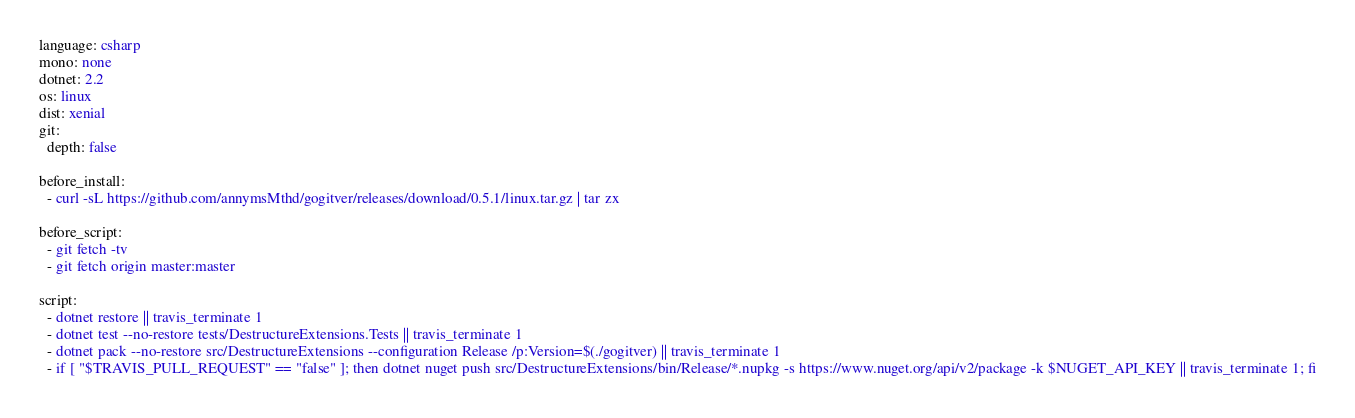<code> <loc_0><loc_0><loc_500><loc_500><_YAML_>language: csharp
mono: none
dotnet: 2.2
os: linux
dist: xenial
git:
  depth: false

before_install:
  - curl -sL https://github.com/annymsMthd/gogitver/releases/download/0.5.1/linux.tar.gz | tar zx

before_script:
  - git fetch -tv
  - git fetch origin master:master

script:
  - dotnet restore || travis_terminate 1
  - dotnet test --no-restore tests/DestructureExtensions.Tests || travis_terminate 1
  - dotnet pack --no-restore src/DestructureExtensions --configuration Release /p:Version=$(./gogitver) || travis_terminate 1
  - if [ "$TRAVIS_PULL_REQUEST" == "false" ]; then dotnet nuget push src/DestructureExtensions/bin/Release/*.nupkg -s https://www.nuget.org/api/v2/package -k $NUGET_API_KEY || travis_terminate 1; fi</code> 